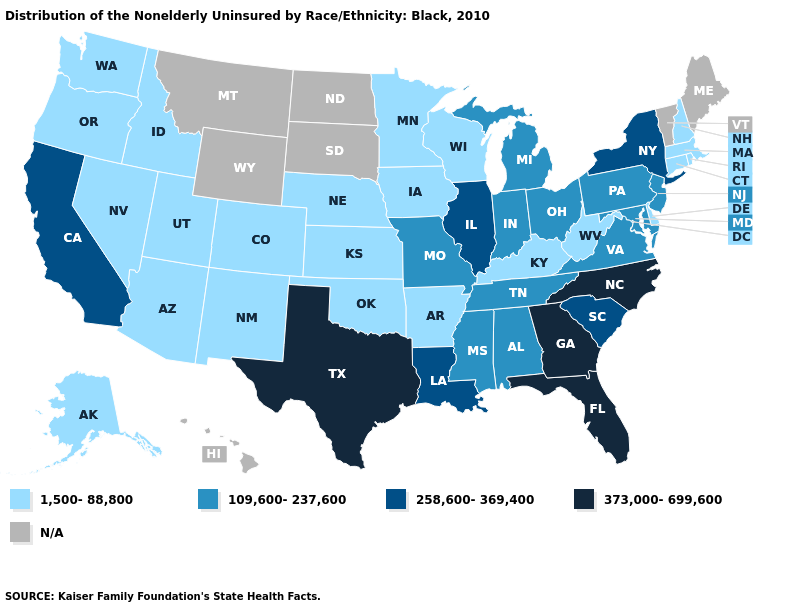What is the highest value in the Northeast ?
Be succinct. 258,600-369,400. Among the states that border Vermont , which have the lowest value?
Be succinct. Massachusetts, New Hampshire. Does Rhode Island have the lowest value in the Northeast?
Quick response, please. Yes. Does Nebraska have the lowest value in the MidWest?
Be succinct. Yes. Which states have the lowest value in the USA?
Quick response, please. Alaska, Arizona, Arkansas, Colorado, Connecticut, Delaware, Idaho, Iowa, Kansas, Kentucky, Massachusetts, Minnesota, Nebraska, Nevada, New Hampshire, New Mexico, Oklahoma, Oregon, Rhode Island, Utah, Washington, West Virginia, Wisconsin. Name the states that have a value in the range N/A?
Answer briefly. Hawaii, Maine, Montana, North Dakota, South Dakota, Vermont, Wyoming. What is the highest value in the USA?
Be succinct. 373,000-699,600. Name the states that have a value in the range 258,600-369,400?
Short answer required. California, Illinois, Louisiana, New York, South Carolina. Which states hav the highest value in the Northeast?
Quick response, please. New York. Does the first symbol in the legend represent the smallest category?
Give a very brief answer. Yes. 